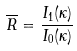<formula> <loc_0><loc_0><loc_500><loc_500>\overline { R } = \frac { I _ { 1 } ( \kappa ) } { I _ { 0 } ( \kappa ) }</formula> 